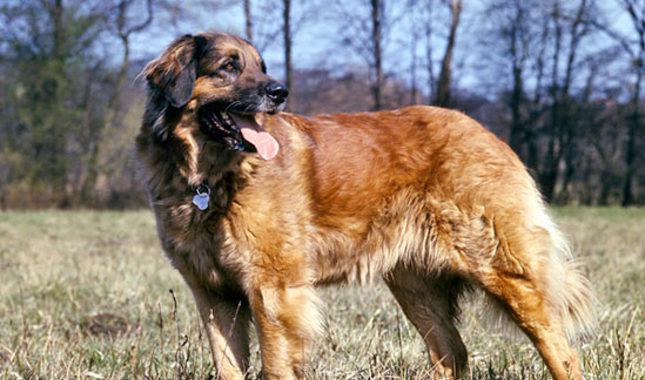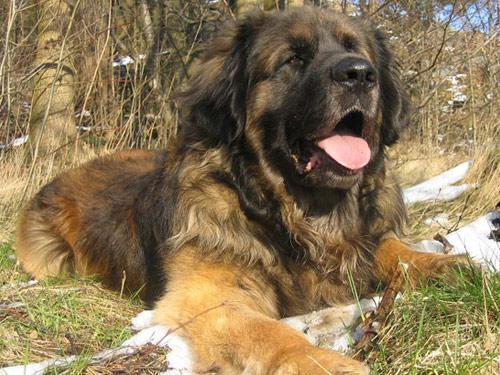The first image is the image on the left, the second image is the image on the right. Examine the images to the left and right. Is the description "One of the dogs is resting on the ground." accurate? Answer yes or no. Yes. 